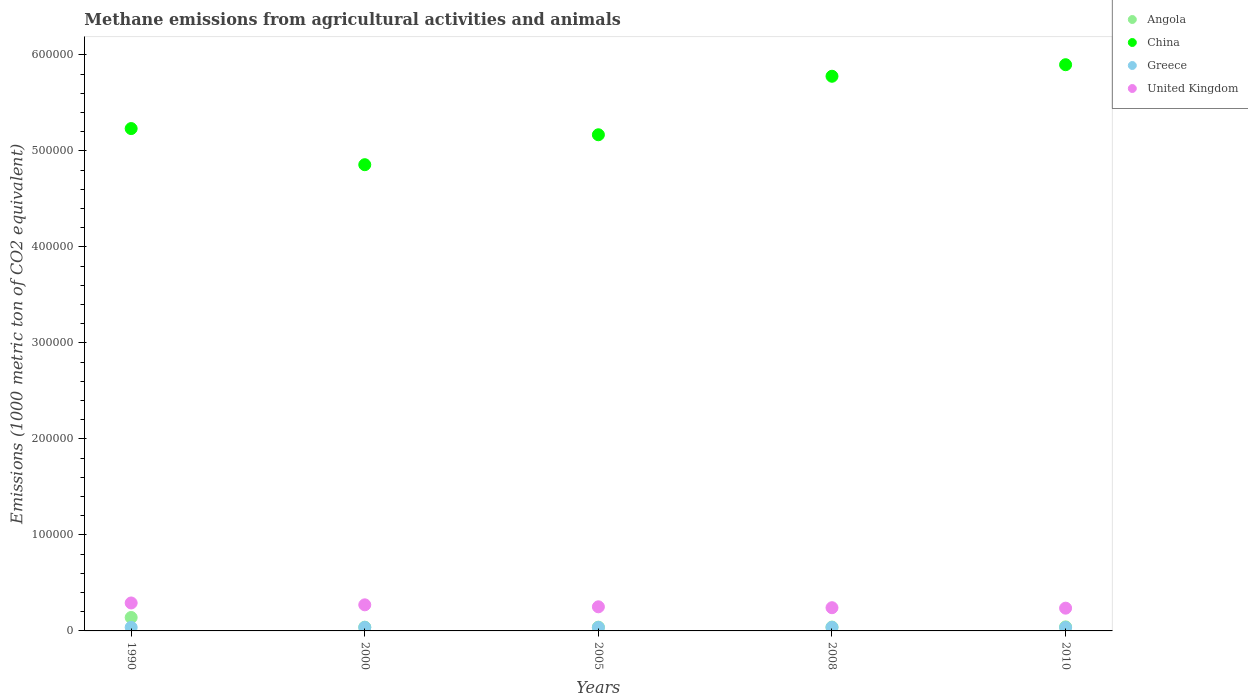What is the amount of methane emitted in China in 2005?
Offer a terse response. 5.17e+05. Across all years, what is the maximum amount of methane emitted in China?
Give a very brief answer. 5.90e+05. Across all years, what is the minimum amount of methane emitted in China?
Give a very brief answer. 4.86e+05. What is the total amount of methane emitted in Angola in the graph?
Provide a succinct answer. 3.00e+04. What is the difference between the amount of methane emitted in United Kingdom in 1990 and that in 2008?
Offer a terse response. 4941.2. What is the difference between the amount of methane emitted in China in 2005 and the amount of methane emitted in Angola in 2010?
Give a very brief answer. 5.13e+05. What is the average amount of methane emitted in United Kingdom per year?
Your answer should be very brief. 2.59e+04. In the year 1990, what is the difference between the amount of methane emitted in Greece and amount of methane emitted in Angola?
Provide a short and direct response. -1.03e+04. What is the ratio of the amount of methane emitted in China in 2000 to that in 2008?
Ensure brevity in your answer.  0.84. Is the amount of methane emitted in China in 2008 less than that in 2010?
Your answer should be very brief. Yes. Is the difference between the amount of methane emitted in Greece in 1990 and 2000 greater than the difference between the amount of methane emitted in Angola in 1990 and 2000?
Keep it short and to the point. No. What is the difference between the highest and the second highest amount of methane emitted in Angola?
Keep it short and to the point. 9807.2. What is the difference between the highest and the lowest amount of methane emitted in China?
Your response must be concise. 1.04e+05. In how many years, is the amount of methane emitted in Angola greater than the average amount of methane emitted in Angola taken over all years?
Provide a short and direct response. 1. Is it the case that in every year, the sum of the amount of methane emitted in United Kingdom and amount of methane emitted in China  is greater than the sum of amount of methane emitted in Greece and amount of methane emitted in Angola?
Keep it short and to the point. Yes. Is it the case that in every year, the sum of the amount of methane emitted in United Kingdom and amount of methane emitted in Angola  is greater than the amount of methane emitted in Greece?
Provide a succinct answer. Yes. Is the amount of methane emitted in China strictly greater than the amount of methane emitted in Greece over the years?
Your answer should be compact. Yes. How many dotlines are there?
Offer a very short reply. 4. How many years are there in the graph?
Keep it short and to the point. 5. Where does the legend appear in the graph?
Give a very brief answer. Top right. How are the legend labels stacked?
Your answer should be compact. Vertical. What is the title of the graph?
Your answer should be very brief. Methane emissions from agricultural activities and animals. What is the label or title of the X-axis?
Ensure brevity in your answer.  Years. What is the label or title of the Y-axis?
Make the answer very short. Emissions (1000 metric ton of CO2 equivalent). What is the Emissions (1000 metric ton of CO2 equivalent) of Angola in 1990?
Your answer should be very brief. 1.40e+04. What is the Emissions (1000 metric ton of CO2 equivalent) in China in 1990?
Provide a succinct answer. 5.23e+05. What is the Emissions (1000 metric ton of CO2 equivalent) of Greece in 1990?
Your answer should be very brief. 3728.5. What is the Emissions (1000 metric ton of CO2 equivalent) of United Kingdom in 1990?
Make the answer very short. 2.91e+04. What is the Emissions (1000 metric ton of CO2 equivalent) in Angola in 2000?
Offer a very short reply. 3884.4. What is the Emissions (1000 metric ton of CO2 equivalent) of China in 2000?
Provide a short and direct response. 4.86e+05. What is the Emissions (1000 metric ton of CO2 equivalent) of Greece in 2000?
Offer a very short reply. 3679.3. What is the Emissions (1000 metric ton of CO2 equivalent) of United Kingdom in 2000?
Offer a terse response. 2.72e+04. What is the Emissions (1000 metric ton of CO2 equivalent) in Angola in 2005?
Provide a short and direct response. 3902.3. What is the Emissions (1000 metric ton of CO2 equivalent) of China in 2005?
Offer a very short reply. 5.17e+05. What is the Emissions (1000 metric ton of CO2 equivalent) of Greece in 2005?
Your answer should be compact. 3644.6. What is the Emissions (1000 metric ton of CO2 equivalent) of United Kingdom in 2005?
Your response must be concise. 2.51e+04. What is the Emissions (1000 metric ton of CO2 equivalent) in Angola in 2008?
Give a very brief answer. 3982. What is the Emissions (1000 metric ton of CO2 equivalent) in China in 2008?
Provide a short and direct response. 5.78e+05. What is the Emissions (1000 metric ton of CO2 equivalent) in Greece in 2008?
Offer a terse response. 3714.1. What is the Emissions (1000 metric ton of CO2 equivalent) in United Kingdom in 2008?
Your response must be concise. 2.42e+04. What is the Emissions (1000 metric ton of CO2 equivalent) of Angola in 2010?
Give a very brief answer. 4188. What is the Emissions (1000 metric ton of CO2 equivalent) of China in 2010?
Offer a very short reply. 5.90e+05. What is the Emissions (1000 metric ton of CO2 equivalent) in Greece in 2010?
Your answer should be compact. 3622.4. What is the Emissions (1000 metric ton of CO2 equivalent) in United Kingdom in 2010?
Offer a terse response. 2.37e+04. Across all years, what is the maximum Emissions (1000 metric ton of CO2 equivalent) in Angola?
Offer a terse response. 1.40e+04. Across all years, what is the maximum Emissions (1000 metric ton of CO2 equivalent) of China?
Ensure brevity in your answer.  5.90e+05. Across all years, what is the maximum Emissions (1000 metric ton of CO2 equivalent) of Greece?
Make the answer very short. 3728.5. Across all years, what is the maximum Emissions (1000 metric ton of CO2 equivalent) of United Kingdom?
Offer a terse response. 2.91e+04. Across all years, what is the minimum Emissions (1000 metric ton of CO2 equivalent) in Angola?
Your answer should be very brief. 3884.4. Across all years, what is the minimum Emissions (1000 metric ton of CO2 equivalent) in China?
Provide a succinct answer. 4.86e+05. Across all years, what is the minimum Emissions (1000 metric ton of CO2 equivalent) in Greece?
Keep it short and to the point. 3622.4. Across all years, what is the minimum Emissions (1000 metric ton of CO2 equivalent) in United Kingdom?
Give a very brief answer. 2.37e+04. What is the total Emissions (1000 metric ton of CO2 equivalent) of Angola in the graph?
Ensure brevity in your answer.  3.00e+04. What is the total Emissions (1000 metric ton of CO2 equivalent) of China in the graph?
Ensure brevity in your answer.  2.69e+06. What is the total Emissions (1000 metric ton of CO2 equivalent) of Greece in the graph?
Offer a terse response. 1.84e+04. What is the total Emissions (1000 metric ton of CO2 equivalent) in United Kingdom in the graph?
Keep it short and to the point. 1.29e+05. What is the difference between the Emissions (1000 metric ton of CO2 equivalent) of Angola in 1990 and that in 2000?
Ensure brevity in your answer.  1.01e+04. What is the difference between the Emissions (1000 metric ton of CO2 equivalent) of China in 1990 and that in 2000?
Provide a succinct answer. 3.76e+04. What is the difference between the Emissions (1000 metric ton of CO2 equivalent) of Greece in 1990 and that in 2000?
Your answer should be compact. 49.2. What is the difference between the Emissions (1000 metric ton of CO2 equivalent) of United Kingdom in 1990 and that in 2000?
Ensure brevity in your answer.  1944.1. What is the difference between the Emissions (1000 metric ton of CO2 equivalent) in Angola in 1990 and that in 2005?
Keep it short and to the point. 1.01e+04. What is the difference between the Emissions (1000 metric ton of CO2 equivalent) in China in 1990 and that in 2005?
Offer a very short reply. 6449.7. What is the difference between the Emissions (1000 metric ton of CO2 equivalent) of Greece in 1990 and that in 2005?
Ensure brevity in your answer.  83.9. What is the difference between the Emissions (1000 metric ton of CO2 equivalent) in United Kingdom in 1990 and that in 2005?
Give a very brief answer. 4004.1. What is the difference between the Emissions (1000 metric ton of CO2 equivalent) of Angola in 1990 and that in 2008?
Provide a short and direct response. 1.00e+04. What is the difference between the Emissions (1000 metric ton of CO2 equivalent) in China in 1990 and that in 2008?
Give a very brief answer. -5.45e+04. What is the difference between the Emissions (1000 metric ton of CO2 equivalent) of United Kingdom in 1990 and that in 2008?
Give a very brief answer. 4941.2. What is the difference between the Emissions (1000 metric ton of CO2 equivalent) in Angola in 1990 and that in 2010?
Offer a terse response. 9807.2. What is the difference between the Emissions (1000 metric ton of CO2 equivalent) in China in 1990 and that in 2010?
Provide a short and direct response. -6.65e+04. What is the difference between the Emissions (1000 metric ton of CO2 equivalent) of Greece in 1990 and that in 2010?
Your answer should be very brief. 106.1. What is the difference between the Emissions (1000 metric ton of CO2 equivalent) in United Kingdom in 1990 and that in 2010?
Your response must be concise. 5414.5. What is the difference between the Emissions (1000 metric ton of CO2 equivalent) in Angola in 2000 and that in 2005?
Your response must be concise. -17.9. What is the difference between the Emissions (1000 metric ton of CO2 equivalent) of China in 2000 and that in 2005?
Give a very brief answer. -3.12e+04. What is the difference between the Emissions (1000 metric ton of CO2 equivalent) of Greece in 2000 and that in 2005?
Ensure brevity in your answer.  34.7. What is the difference between the Emissions (1000 metric ton of CO2 equivalent) in United Kingdom in 2000 and that in 2005?
Offer a terse response. 2060. What is the difference between the Emissions (1000 metric ton of CO2 equivalent) in Angola in 2000 and that in 2008?
Give a very brief answer. -97.6. What is the difference between the Emissions (1000 metric ton of CO2 equivalent) in China in 2000 and that in 2008?
Your response must be concise. -9.21e+04. What is the difference between the Emissions (1000 metric ton of CO2 equivalent) of Greece in 2000 and that in 2008?
Provide a succinct answer. -34.8. What is the difference between the Emissions (1000 metric ton of CO2 equivalent) in United Kingdom in 2000 and that in 2008?
Offer a very short reply. 2997.1. What is the difference between the Emissions (1000 metric ton of CO2 equivalent) of Angola in 2000 and that in 2010?
Provide a succinct answer. -303.6. What is the difference between the Emissions (1000 metric ton of CO2 equivalent) in China in 2000 and that in 2010?
Your response must be concise. -1.04e+05. What is the difference between the Emissions (1000 metric ton of CO2 equivalent) in Greece in 2000 and that in 2010?
Your answer should be very brief. 56.9. What is the difference between the Emissions (1000 metric ton of CO2 equivalent) of United Kingdom in 2000 and that in 2010?
Keep it short and to the point. 3470.4. What is the difference between the Emissions (1000 metric ton of CO2 equivalent) of Angola in 2005 and that in 2008?
Give a very brief answer. -79.7. What is the difference between the Emissions (1000 metric ton of CO2 equivalent) in China in 2005 and that in 2008?
Keep it short and to the point. -6.10e+04. What is the difference between the Emissions (1000 metric ton of CO2 equivalent) of Greece in 2005 and that in 2008?
Provide a succinct answer. -69.5. What is the difference between the Emissions (1000 metric ton of CO2 equivalent) of United Kingdom in 2005 and that in 2008?
Ensure brevity in your answer.  937.1. What is the difference between the Emissions (1000 metric ton of CO2 equivalent) in Angola in 2005 and that in 2010?
Your answer should be very brief. -285.7. What is the difference between the Emissions (1000 metric ton of CO2 equivalent) in China in 2005 and that in 2010?
Give a very brief answer. -7.30e+04. What is the difference between the Emissions (1000 metric ton of CO2 equivalent) of Greece in 2005 and that in 2010?
Your answer should be very brief. 22.2. What is the difference between the Emissions (1000 metric ton of CO2 equivalent) of United Kingdom in 2005 and that in 2010?
Your answer should be compact. 1410.4. What is the difference between the Emissions (1000 metric ton of CO2 equivalent) in Angola in 2008 and that in 2010?
Keep it short and to the point. -206. What is the difference between the Emissions (1000 metric ton of CO2 equivalent) in China in 2008 and that in 2010?
Keep it short and to the point. -1.20e+04. What is the difference between the Emissions (1000 metric ton of CO2 equivalent) of Greece in 2008 and that in 2010?
Your answer should be very brief. 91.7. What is the difference between the Emissions (1000 metric ton of CO2 equivalent) in United Kingdom in 2008 and that in 2010?
Your answer should be very brief. 473.3. What is the difference between the Emissions (1000 metric ton of CO2 equivalent) of Angola in 1990 and the Emissions (1000 metric ton of CO2 equivalent) of China in 2000?
Your answer should be compact. -4.72e+05. What is the difference between the Emissions (1000 metric ton of CO2 equivalent) of Angola in 1990 and the Emissions (1000 metric ton of CO2 equivalent) of Greece in 2000?
Offer a terse response. 1.03e+04. What is the difference between the Emissions (1000 metric ton of CO2 equivalent) in Angola in 1990 and the Emissions (1000 metric ton of CO2 equivalent) in United Kingdom in 2000?
Give a very brief answer. -1.32e+04. What is the difference between the Emissions (1000 metric ton of CO2 equivalent) of China in 1990 and the Emissions (1000 metric ton of CO2 equivalent) of Greece in 2000?
Offer a very short reply. 5.20e+05. What is the difference between the Emissions (1000 metric ton of CO2 equivalent) in China in 1990 and the Emissions (1000 metric ton of CO2 equivalent) in United Kingdom in 2000?
Your response must be concise. 4.96e+05. What is the difference between the Emissions (1000 metric ton of CO2 equivalent) of Greece in 1990 and the Emissions (1000 metric ton of CO2 equivalent) of United Kingdom in 2000?
Provide a succinct answer. -2.34e+04. What is the difference between the Emissions (1000 metric ton of CO2 equivalent) in Angola in 1990 and the Emissions (1000 metric ton of CO2 equivalent) in China in 2005?
Offer a terse response. -5.03e+05. What is the difference between the Emissions (1000 metric ton of CO2 equivalent) of Angola in 1990 and the Emissions (1000 metric ton of CO2 equivalent) of Greece in 2005?
Your response must be concise. 1.04e+04. What is the difference between the Emissions (1000 metric ton of CO2 equivalent) of Angola in 1990 and the Emissions (1000 metric ton of CO2 equivalent) of United Kingdom in 2005?
Your answer should be very brief. -1.11e+04. What is the difference between the Emissions (1000 metric ton of CO2 equivalent) in China in 1990 and the Emissions (1000 metric ton of CO2 equivalent) in Greece in 2005?
Provide a short and direct response. 5.20e+05. What is the difference between the Emissions (1000 metric ton of CO2 equivalent) in China in 1990 and the Emissions (1000 metric ton of CO2 equivalent) in United Kingdom in 2005?
Your answer should be very brief. 4.98e+05. What is the difference between the Emissions (1000 metric ton of CO2 equivalent) in Greece in 1990 and the Emissions (1000 metric ton of CO2 equivalent) in United Kingdom in 2005?
Your response must be concise. -2.14e+04. What is the difference between the Emissions (1000 metric ton of CO2 equivalent) in Angola in 1990 and the Emissions (1000 metric ton of CO2 equivalent) in China in 2008?
Your response must be concise. -5.64e+05. What is the difference between the Emissions (1000 metric ton of CO2 equivalent) of Angola in 1990 and the Emissions (1000 metric ton of CO2 equivalent) of Greece in 2008?
Your answer should be compact. 1.03e+04. What is the difference between the Emissions (1000 metric ton of CO2 equivalent) of Angola in 1990 and the Emissions (1000 metric ton of CO2 equivalent) of United Kingdom in 2008?
Your answer should be compact. -1.02e+04. What is the difference between the Emissions (1000 metric ton of CO2 equivalent) of China in 1990 and the Emissions (1000 metric ton of CO2 equivalent) of Greece in 2008?
Make the answer very short. 5.20e+05. What is the difference between the Emissions (1000 metric ton of CO2 equivalent) of China in 1990 and the Emissions (1000 metric ton of CO2 equivalent) of United Kingdom in 2008?
Keep it short and to the point. 4.99e+05. What is the difference between the Emissions (1000 metric ton of CO2 equivalent) of Greece in 1990 and the Emissions (1000 metric ton of CO2 equivalent) of United Kingdom in 2008?
Your answer should be compact. -2.05e+04. What is the difference between the Emissions (1000 metric ton of CO2 equivalent) of Angola in 1990 and the Emissions (1000 metric ton of CO2 equivalent) of China in 2010?
Make the answer very short. -5.76e+05. What is the difference between the Emissions (1000 metric ton of CO2 equivalent) in Angola in 1990 and the Emissions (1000 metric ton of CO2 equivalent) in Greece in 2010?
Provide a short and direct response. 1.04e+04. What is the difference between the Emissions (1000 metric ton of CO2 equivalent) of Angola in 1990 and the Emissions (1000 metric ton of CO2 equivalent) of United Kingdom in 2010?
Make the answer very short. -9712.6. What is the difference between the Emissions (1000 metric ton of CO2 equivalent) of China in 1990 and the Emissions (1000 metric ton of CO2 equivalent) of Greece in 2010?
Provide a short and direct response. 5.20e+05. What is the difference between the Emissions (1000 metric ton of CO2 equivalent) of China in 1990 and the Emissions (1000 metric ton of CO2 equivalent) of United Kingdom in 2010?
Offer a terse response. 5.00e+05. What is the difference between the Emissions (1000 metric ton of CO2 equivalent) in Greece in 1990 and the Emissions (1000 metric ton of CO2 equivalent) in United Kingdom in 2010?
Your answer should be very brief. -2.00e+04. What is the difference between the Emissions (1000 metric ton of CO2 equivalent) in Angola in 2000 and the Emissions (1000 metric ton of CO2 equivalent) in China in 2005?
Offer a very short reply. -5.13e+05. What is the difference between the Emissions (1000 metric ton of CO2 equivalent) in Angola in 2000 and the Emissions (1000 metric ton of CO2 equivalent) in Greece in 2005?
Ensure brevity in your answer.  239.8. What is the difference between the Emissions (1000 metric ton of CO2 equivalent) of Angola in 2000 and the Emissions (1000 metric ton of CO2 equivalent) of United Kingdom in 2005?
Your answer should be very brief. -2.12e+04. What is the difference between the Emissions (1000 metric ton of CO2 equivalent) of China in 2000 and the Emissions (1000 metric ton of CO2 equivalent) of Greece in 2005?
Provide a succinct answer. 4.82e+05. What is the difference between the Emissions (1000 metric ton of CO2 equivalent) of China in 2000 and the Emissions (1000 metric ton of CO2 equivalent) of United Kingdom in 2005?
Ensure brevity in your answer.  4.61e+05. What is the difference between the Emissions (1000 metric ton of CO2 equivalent) in Greece in 2000 and the Emissions (1000 metric ton of CO2 equivalent) in United Kingdom in 2005?
Offer a very short reply. -2.14e+04. What is the difference between the Emissions (1000 metric ton of CO2 equivalent) of Angola in 2000 and the Emissions (1000 metric ton of CO2 equivalent) of China in 2008?
Provide a succinct answer. -5.74e+05. What is the difference between the Emissions (1000 metric ton of CO2 equivalent) of Angola in 2000 and the Emissions (1000 metric ton of CO2 equivalent) of Greece in 2008?
Offer a terse response. 170.3. What is the difference between the Emissions (1000 metric ton of CO2 equivalent) in Angola in 2000 and the Emissions (1000 metric ton of CO2 equivalent) in United Kingdom in 2008?
Provide a short and direct response. -2.03e+04. What is the difference between the Emissions (1000 metric ton of CO2 equivalent) in China in 2000 and the Emissions (1000 metric ton of CO2 equivalent) in Greece in 2008?
Provide a succinct answer. 4.82e+05. What is the difference between the Emissions (1000 metric ton of CO2 equivalent) of China in 2000 and the Emissions (1000 metric ton of CO2 equivalent) of United Kingdom in 2008?
Offer a very short reply. 4.62e+05. What is the difference between the Emissions (1000 metric ton of CO2 equivalent) of Greece in 2000 and the Emissions (1000 metric ton of CO2 equivalent) of United Kingdom in 2008?
Offer a very short reply. -2.05e+04. What is the difference between the Emissions (1000 metric ton of CO2 equivalent) of Angola in 2000 and the Emissions (1000 metric ton of CO2 equivalent) of China in 2010?
Offer a terse response. -5.86e+05. What is the difference between the Emissions (1000 metric ton of CO2 equivalent) of Angola in 2000 and the Emissions (1000 metric ton of CO2 equivalent) of Greece in 2010?
Provide a short and direct response. 262. What is the difference between the Emissions (1000 metric ton of CO2 equivalent) of Angola in 2000 and the Emissions (1000 metric ton of CO2 equivalent) of United Kingdom in 2010?
Your response must be concise. -1.98e+04. What is the difference between the Emissions (1000 metric ton of CO2 equivalent) in China in 2000 and the Emissions (1000 metric ton of CO2 equivalent) in Greece in 2010?
Make the answer very short. 4.82e+05. What is the difference between the Emissions (1000 metric ton of CO2 equivalent) of China in 2000 and the Emissions (1000 metric ton of CO2 equivalent) of United Kingdom in 2010?
Keep it short and to the point. 4.62e+05. What is the difference between the Emissions (1000 metric ton of CO2 equivalent) in Greece in 2000 and the Emissions (1000 metric ton of CO2 equivalent) in United Kingdom in 2010?
Make the answer very short. -2.00e+04. What is the difference between the Emissions (1000 metric ton of CO2 equivalent) in Angola in 2005 and the Emissions (1000 metric ton of CO2 equivalent) in China in 2008?
Keep it short and to the point. -5.74e+05. What is the difference between the Emissions (1000 metric ton of CO2 equivalent) in Angola in 2005 and the Emissions (1000 metric ton of CO2 equivalent) in Greece in 2008?
Make the answer very short. 188.2. What is the difference between the Emissions (1000 metric ton of CO2 equivalent) of Angola in 2005 and the Emissions (1000 metric ton of CO2 equivalent) of United Kingdom in 2008?
Your answer should be very brief. -2.03e+04. What is the difference between the Emissions (1000 metric ton of CO2 equivalent) of China in 2005 and the Emissions (1000 metric ton of CO2 equivalent) of Greece in 2008?
Ensure brevity in your answer.  5.13e+05. What is the difference between the Emissions (1000 metric ton of CO2 equivalent) in China in 2005 and the Emissions (1000 metric ton of CO2 equivalent) in United Kingdom in 2008?
Provide a succinct answer. 4.93e+05. What is the difference between the Emissions (1000 metric ton of CO2 equivalent) in Greece in 2005 and the Emissions (1000 metric ton of CO2 equivalent) in United Kingdom in 2008?
Keep it short and to the point. -2.05e+04. What is the difference between the Emissions (1000 metric ton of CO2 equivalent) in Angola in 2005 and the Emissions (1000 metric ton of CO2 equivalent) in China in 2010?
Give a very brief answer. -5.86e+05. What is the difference between the Emissions (1000 metric ton of CO2 equivalent) of Angola in 2005 and the Emissions (1000 metric ton of CO2 equivalent) of Greece in 2010?
Offer a terse response. 279.9. What is the difference between the Emissions (1000 metric ton of CO2 equivalent) of Angola in 2005 and the Emissions (1000 metric ton of CO2 equivalent) of United Kingdom in 2010?
Offer a very short reply. -1.98e+04. What is the difference between the Emissions (1000 metric ton of CO2 equivalent) of China in 2005 and the Emissions (1000 metric ton of CO2 equivalent) of Greece in 2010?
Keep it short and to the point. 5.13e+05. What is the difference between the Emissions (1000 metric ton of CO2 equivalent) in China in 2005 and the Emissions (1000 metric ton of CO2 equivalent) in United Kingdom in 2010?
Offer a very short reply. 4.93e+05. What is the difference between the Emissions (1000 metric ton of CO2 equivalent) in Greece in 2005 and the Emissions (1000 metric ton of CO2 equivalent) in United Kingdom in 2010?
Your answer should be very brief. -2.01e+04. What is the difference between the Emissions (1000 metric ton of CO2 equivalent) in Angola in 2008 and the Emissions (1000 metric ton of CO2 equivalent) in China in 2010?
Offer a very short reply. -5.86e+05. What is the difference between the Emissions (1000 metric ton of CO2 equivalent) in Angola in 2008 and the Emissions (1000 metric ton of CO2 equivalent) in Greece in 2010?
Your response must be concise. 359.6. What is the difference between the Emissions (1000 metric ton of CO2 equivalent) of Angola in 2008 and the Emissions (1000 metric ton of CO2 equivalent) of United Kingdom in 2010?
Provide a short and direct response. -1.97e+04. What is the difference between the Emissions (1000 metric ton of CO2 equivalent) in China in 2008 and the Emissions (1000 metric ton of CO2 equivalent) in Greece in 2010?
Your answer should be very brief. 5.74e+05. What is the difference between the Emissions (1000 metric ton of CO2 equivalent) in China in 2008 and the Emissions (1000 metric ton of CO2 equivalent) in United Kingdom in 2010?
Make the answer very short. 5.54e+05. What is the difference between the Emissions (1000 metric ton of CO2 equivalent) of Greece in 2008 and the Emissions (1000 metric ton of CO2 equivalent) of United Kingdom in 2010?
Give a very brief answer. -2.00e+04. What is the average Emissions (1000 metric ton of CO2 equivalent) of Angola per year?
Offer a very short reply. 5990.38. What is the average Emissions (1000 metric ton of CO2 equivalent) of China per year?
Keep it short and to the point. 5.39e+05. What is the average Emissions (1000 metric ton of CO2 equivalent) in Greece per year?
Provide a succinct answer. 3677.78. What is the average Emissions (1000 metric ton of CO2 equivalent) of United Kingdom per year?
Offer a terse response. 2.59e+04. In the year 1990, what is the difference between the Emissions (1000 metric ton of CO2 equivalent) in Angola and Emissions (1000 metric ton of CO2 equivalent) in China?
Offer a terse response. -5.09e+05. In the year 1990, what is the difference between the Emissions (1000 metric ton of CO2 equivalent) in Angola and Emissions (1000 metric ton of CO2 equivalent) in Greece?
Ensure brevity in your answer.  1.03e+04. In the year 1990, what is the difference between the Emissions (1000 metric ton of CO2 equivalent) in Angola and Emissions (1000 metric ton of CO2 equivalent) in United Kingdom?
Offer a terse response. -1.51e+04. In the year 1990, what is the difference between the Emissions (1000 metric ton of CO2 equivalent) in China and Emissions (1000 metric ton of CO2 equivalent) in Greece?
Keep it short and to the point. 5.20e+05. In the year 1990, what is the difference between the Emissions (1000 metric ton of CO2 equivalent) in China and Emissions (1000 metric ton of CO2 equivalent) in United Kingdom?
Your response must be concise. 4.94e+05. In the year 1990, what is the difference between the Emissions (1000 metric ton of CO2 equivalent) of Greece and Emissions (1000 metric ton of CO2 equivalent) of United Kingdom?
Provide a short and direct response. -2.54e+04. In the year 2000, what is the difference between the Emissions (1000 metric ton of CO2 equivalent) of Angola and Emissions (1000 metric ton of CO2 equivalent) of China?
Your response must be concise. -4.82e+05. In the year 2000, what is the difference between the Emissions (1000 metric ton of CO2 equivalent) of Angola and Emissions (1000 metric ton of CO2 equivalent) of Greece?
Keep it short and to the point. 205.1. In the year 2000, what is the difference between the Emissions (1000 metric ton of CO2 equivalent) in Angola and Emissions (1000 metric ton of CO2 equivalent) in United Kingdom?
Your response must be concise. -2.33e+04. In the year 2000, what is the difference between the Emissions (1000 metric ton of CO2 equivalent) in China and Emissions (1000 metric ton of CO2 equivalent) in Greece?
Give a very brief answer. 4.82e+05. In the year 2000, what is the difference between the Emissions (1000 metric ton of CO2 equivalent) in China and Emissions (1000 metric ton of CO2 equivalent) in United Kingdom?
Make the answer very short. 4.59e+05. In the year 2000, what is the difference between the Emissions (1000 metric ton of CO2 equivalent) in Greece and Emissions (1000 metric ton of CO2 equivalent) in United Kingdom?
Your response must be concise. -2.35e+04. In the year 2005, what is the difference between the Emissions (1000 metric ton of CO2 equivalent) of Angola and Emissions (1000 metric ton of CO2 equivalent) of China?
Offer a very short reply. -5.13e+05. In the year 2005, what is the difference between the Emissions (1000 metric ton of CO2 equivalent) in Angola and Emissions (1000 metric ton of CO2 equivalent) in Greece?
Offer a very short reply. 257.7. In the year 2005, what is the difference between the Emissions (1000 metric ton of CO2 equivalent) in Angola and Emissions (1000 metric ton of CO2 equivalent) in United Kingdom?
Keep it short and to the point. -2.12e+04. In the year 2005, what is the difference between the Emissions (1000 metric ton of CO2 equivalent) in China and Emissions (1000 metric ton of CO2 equivalent) in Greece?
Provide a succinct answer. 5.13e+05. In the year 2005, what is the difference between the Emissions (1000 metric ton of CO2 equivalent) of China and Emissions (1000 metric ton of CO2 equivalent) of United Kingdom?
Offer a terse response. 4.92e+05. In the year 2005, what is the difference between the Emissions (1000 metric ton of CO2 equivalent) of Greece and Emissions (1000 metric ton of CO2 equivalent) of United Kingdom?
Provide a succinct answer. -2.15e+04. In the year 2008, what is the difference between the Emissions (1000 metric ton of CO2 equivalent) of Angola and Emissions (1000 metric ton of CO2 equivalent) of China?
Provide a succinct answer. -5.74e+05. In the year 2008, what is the difference between the Emissions (1000 metric ton of CO2 equivalent) of Angola and Emissions (1000 metric ton of CO2 equivalent) of Greece?
Ensure brevity in your answer.  267.9. In the year 2008, what is the difference between the Emissions (1000 metric ton of CO2 equivalent) of Angola and Emissions (1000 metric ton of CO2 equivalent) of United Kingdom?
Give a very brief answer. -2.02e+04. In the year 2008, what is the difference between the Emissions (1000 metric ton of CO2 equivalent) in China and Emissions (1000 metric ton of CO2 equivalent) in Greece?
Your response must be concise. 5.74e+05. In the year 2008, what is the difference between the Emissions (1000 metric ton of CO2 equivalent) in China and Emissions (1000 metric ton of CO2 equivalent) in United Kingdom?
Give a very brief answer. 5.54e+05. In the year 2008, what is the difference between the Emissions (1000 metric ton of CO2 equivalent) in Greece and Emissions (1000 metric ton of CO2 equivalent) in United Kingdom?
Ensure brevity in your answer.  -2.05e+04. In the year 2010, what is the difference between the Emissions (1000 metric ton of CO2 equivalent) in Angola and Emissions (1000 metric ton of CO2 equivalent) in China?
Make the answer very short. -5.86e+05. In the year 2010, what is the difference between the Emissions (1000 metric ton of CO2 equivalent) of Angola and Emissions (1000 metric ton of CO2 equivalent) of Greece?
Provide a succinct answer. 565.6. In the year 2010, what is the difference between the Emissions (1000 metric ton of CO2 equivalent) of Angola and Emissions (1000 metric ton of CO2 equivalent) of United Kingdom?
Provide a succinct answer. -1.95e+04. In the year 2010, what is the difference between the Emissions (1000 metric ton of CO2 equivalent) of China and Emissions (1000 metric ton of CO2 equivalent) of Greece?
Your answer should be compact. 5.86e+05. In the year 2010, what is the difference between the Emissions (1000 metric ton of CO2 equivalent) of China and Emissions (1000 metric ton of CO2 equivalent) of United Kingdom?
Offer a terse response. 5.66e+05. In the year 2010, what is the difference between the Emissions (1000 metric ton of CO2 equivalent) of Greece and Emissions (1000 metric ton of CO2 equivalent) of United Kingdom?
Offer a terse response. -2.01e+04. What is the ratio of the Emissions (1000 metric ton of CO2 equivalent) of Angola in 1990 to that in 2000?
Provide a succinct answer. 3.6. What is the ratio of the Emissions (1000 metric ton of CO2 equivalent) in China in 1990 to that in 2000?
Provide a succinct answer. 1.08. What is the ratio of the Emissions (1000 metric ton of CO2 equivalent) of Greece in 1990 to that in 2000?
Provide a succinct answer. 1.01. What is the ratio of the Emissions (1000 metric ton of CO2 equivalent) in United Kingdom in 1990 to that in 2000?
Your answer should be compact. 1.07. What is the ratio of the Emissions (1000 metric ton of CO2 equivalent) in Angola in 1990 to that in 2005?
Give a very brief answer. 3.59. What is the ratio of the Emissions (1000 metric ton of CO2 equivalent) of China in 1990 to that in 2005?
Provide a succinct answer. 1.01. What is the ratio of the Emissions (1000 metric ton of CO2 equivalent) in Greece in 1990 to that in 2005?
Your response must be concise. 1.02. What is the ratio of the Emissions (1000 metric ton of CO2 equivalent) of United Kingdom in 1990 to that in 2005?
Ensure brevity in your answer.  1.16. What is the ratio of the Emissions (1000 metric ton of CO2 equivalent) in Angola in 1990 to that in 2008?
Provide a succinct answer. 3.51. What is the ratio of the Emissions (1000 metric ton of CO2 equivalent) of China in 1990 to that in 2008?
Offer a terse response. 0.91. What is the ratio of the Emissions (1000 metric ton of CO2 equivalent) in Greece in 1990 to that in 2008?
Give a very brief answer. 1. What is the ratio of the Emissions (1000 metric ton of CO2 equivalent) of United Kingdom in 1990 to that in 2008?
Your answer should be very brief. 1.2. What is the ratio of the Emissions (1000 metric ton of CO2 equivalent) of Angola in 1990 to that in 2010?
Your answer should be compact. 3.34. What is the ratio of the Emissions (1000 metric ton of CO2 equivalent) in China in 1990 to that in 2010?
Offer a very short reply. 0.89. What is the ratio of the Emissions (1000 metric ton of CO2 equivalent) of Greece in 1990 to that in 2010?
Provide a succinct answer. 1.03. What is the ratio of the Emissions (1000 metric ton of CO2 equivalent) in United Kingdom in 1990 to that in 2010?
Ensure brevity in your answer.  1.23. What is the ratio of the Emissions (1000 metric ton of CO2 equivalent) of Angola in 2000 to that in 2005?
Offer a very short reply. 1. What is the ratio of the Emissions (1000 metric ton of CO2 equivalent) of China in 2000 to that in 2005?
Give a very brief answer. 0.94. What is the ratio of the Emissions (1000 metric ton of CO2 equivalent) in Greece in 2000 to that in 2005?
Offer a very short reply. 1.01. What is the ratio of the Emissions (1000 metric ton of CO2 equivalent) in United Kingdom in 2000 to that in 2005?
Your answer should be very brief. 1.08. What is the ratio of the Emissions (1000 metric ton of CO2 equivalent) of Angola in 2000 to that in 2008?
Your answer should be compact. 0.98. What is the ratio of the Emissions (1000 metric ton of CO2 equivalent) in China in 2000 to that in 2008?
Provide a short and direct response. 0.84. What is the ratio of the Emissions (1000 metric ton of CO2 equivalent) of Greece in 2000 to that in 2008?
Your response must be concise. 0.99. What is the ratio of the Emissions (1000 metric ton of CO2 equivalent) of United Kingdom in 2000 to that in 2008?
Offer a very short reply. 1.12. What is the ratio of the Emissions (1000 metric ton of CO2 equivalent) of Angola in 2000 to that in 2010?
Provide a short and direct response. 0.93. What is the ratio of the Emissions (1000 metric ton of CO2 equivalent) in China in 2000 to that in 2010?
Offer a very short reply. 0.82. What is the ratio of the Emissions (1000 metric ton of CO2 equivalent) in Greece in 2000 to that in 2010?
Give a very brief answer. 1.02. What is the ratio of the Emissions (1000 metric ton of CO2 equivalent) of United Kingdom in 2000 to that in 2010?
Offer a very short reply. 1.15. What is the ratio of the Emissions (1000 metric ton of CO2 equivalent) in Angola in 2005 to that in 2008?
Keep it short and to the point. 0.98. What is the ratio of the Emissions (1000 metric ton of CO2 equivalent) in China in 2005 to that in 2008?
Your answer should be compact. 0.89. What is the ratio of the Emissions (1000 metric ton of CO2 equivalent) of Greece in 2005 to that in 2008?
Keep it short and to the point. 0.98. What is the ratio of the Emissions (1000 metric ton of CO2 equivalent) in United Kingdom in 2005 to that in 2008?
Your answer should be very brief. 1.04. What is the ratio of the Emissions (1000 metric ton of CO2 equivalent) in Angola in 2005 to that in 2010?
Provide a short and direct response. 0.93. What is the ratio of the Emissions (1000 metric ton of CO2 equivalent) of China in 2005 to that in 2010?
Offer a very short reply. 0.88. What is the ratio of the Emissions (1000 metric ton of CO2 equivalent) of United Kingdom in 2005 to that in 2010?
Offer a terse response. 1.06. What is the ratio of the Emissions (1000 metric ton of CO2 equivalent) of Angola in 2008 to that in 2010?
Make the answer very short. 0.95. What is the ratio of the Emissions (1000 metric ton of CO2 equivalent) in China in 2008 to that in 2010?
Offer a very short reply. 0.98. What is the ratio of the Emissions (1000 metric ton of CO2 equivalent) of Greece in 2008 to that in 2010?
Your response must be concise. 1.03. What is the ratio of the Emissions (1000 metric ton of CO2 equivalent) in United Kingdom in 2008 to that in 2010?
Keep it short and to the point. 1.02. What is the difference between the highest and the second highest Emissions (1000 metric ton of CO2 equivalent) in Angola?
Offer a very short reply. 9807.2. What is the difference between the highest and the second highest Emissions (1000 metric ton of CO2 equivalent) of China?
Offer a very short reply. 1.20e+04. What is the difference between the highest and the second highest Emissions (1000 metric ton of CO2 equivalent) of United Kingdom?
Your response must be concise. 1944.1. What is the difference between the highest and the lowest Emissions (1000 metric ton of CO2 equivalent) in Angola?
Ensure brevity in your answer.  1.01e+04. What is the difference between the highest and the lowest Emissions (1000 metric ton of CO2 equivalent) of China?
Ensure brevity in your answer.  1.04e+05. What is the difference between the highest and the lowest Emissions (1000 metric ton of CO2 equivalent) in Greece?
Provide a succinct answer. 106.1. What is the difference between the highest and the lowest Emissions (1000 metric ton of CO2 equivalent) of United Kingdom?
Give a very brief answer. 5414.5. 